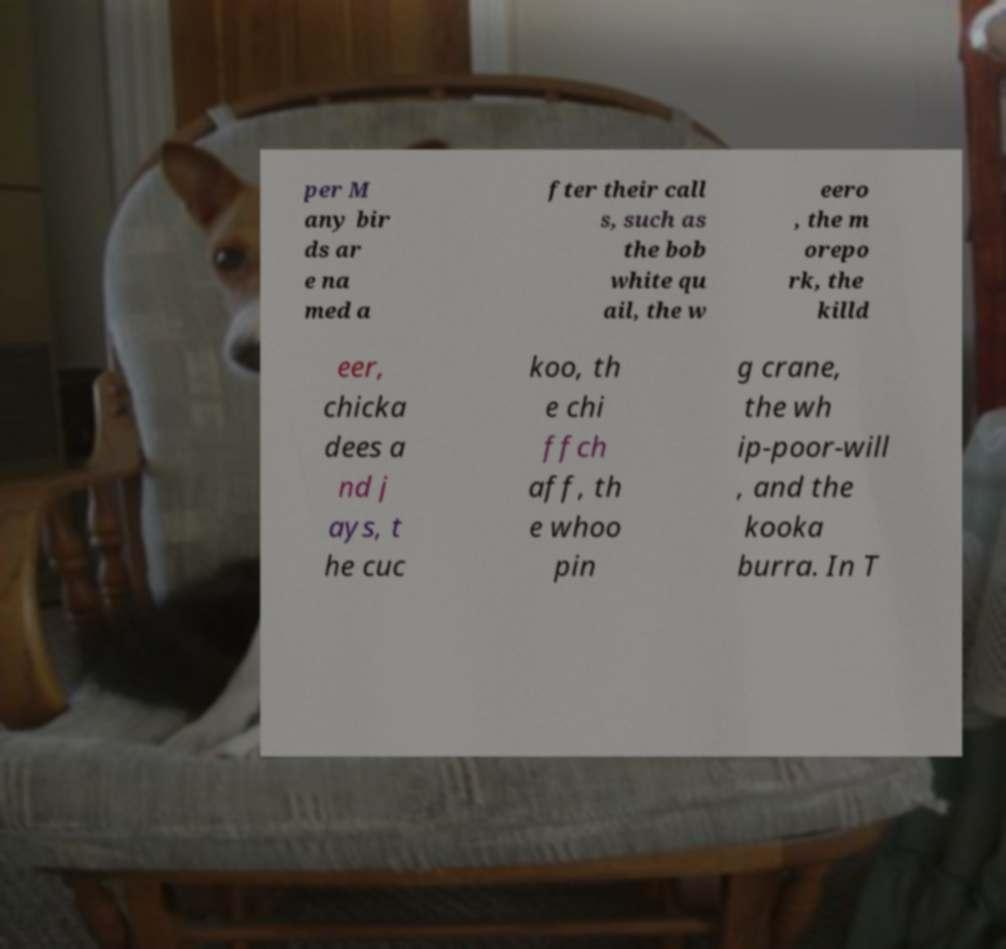Please identify and transcribe the text found in this image. per M any bir ds ar e na med a fter their call s, such as the bob white qu ail, the w eero , the m orepo rk, the killd eer, chicka dees a nd j ays, t he cuc koo, th e chi ffch aff, th e whoo pin g crane, the wh ip-poor-will , and the kooka burra. In T 